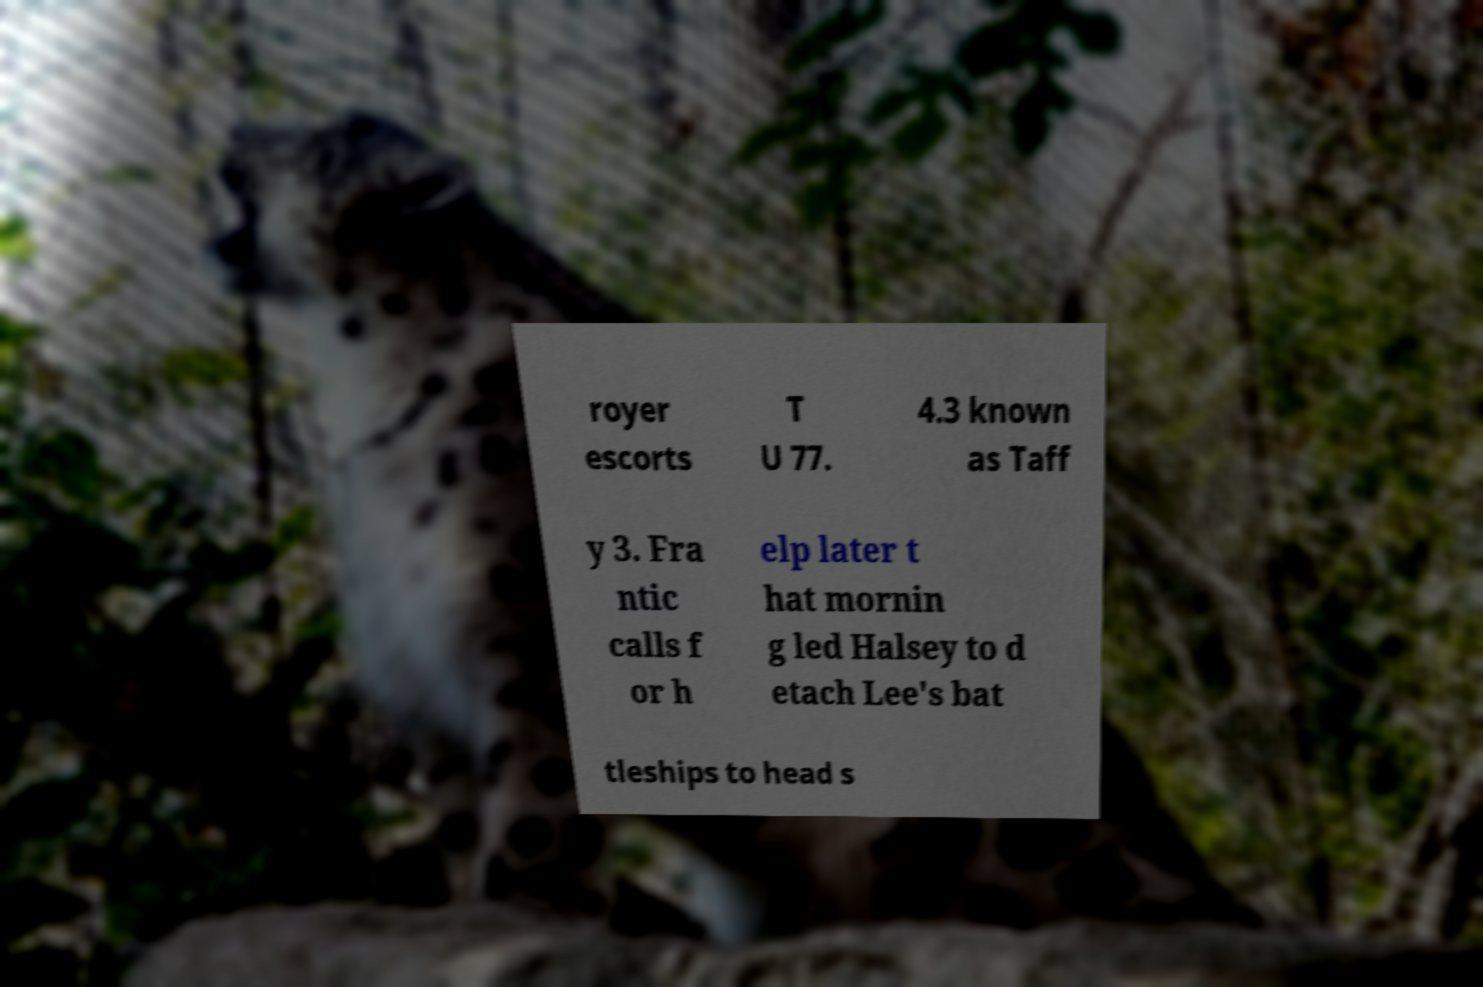Can you accurately transcribe the text from the provided image for me? royer escorts T U 77. 4.3 known as Taff y 3. Fra ntic calls f or h elp later t hat mornin g led Halsey to d etach Lee's bat tleships to head s 